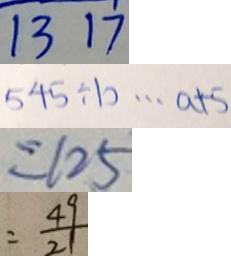<formula> <loc_0><loc_0><loc_500><loc_500>1 3 1 7 
 5 4 5 \div b \cdots a + 5 
 = 1 2 5 
 = \frac { 4 9 } { 2 1 }</formula> 